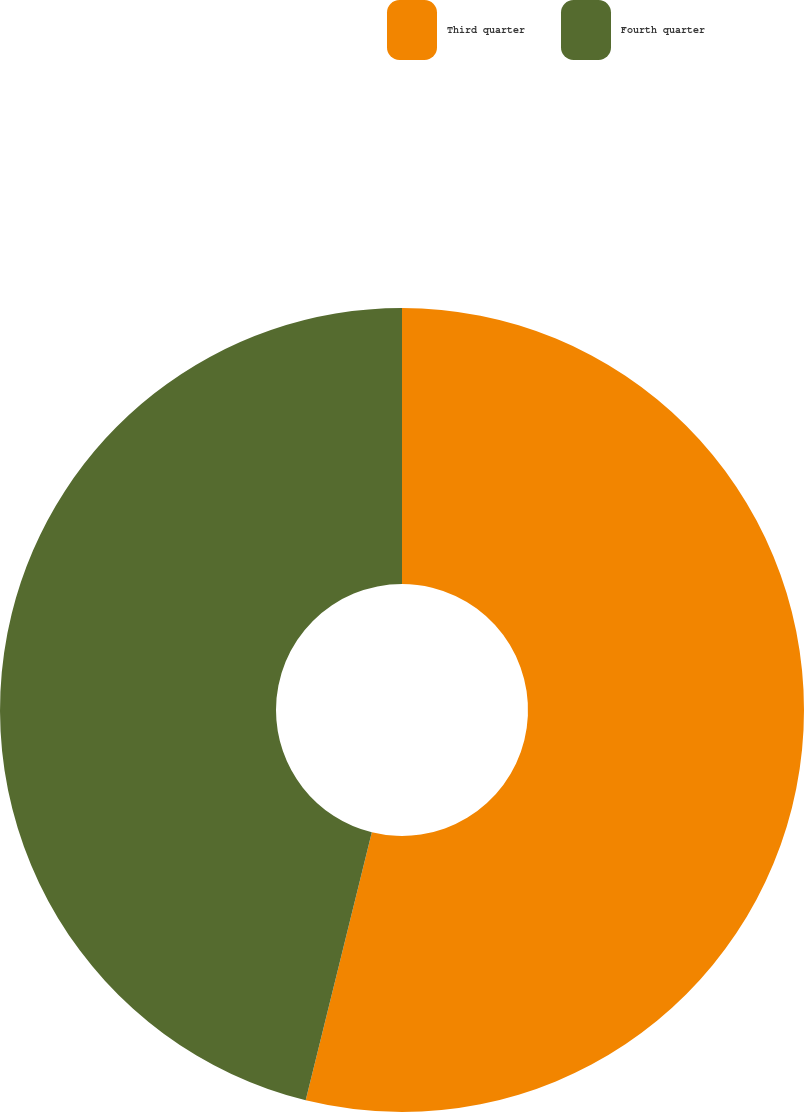Convert chart to OTSL. <chart><loc_0><loc_0><loc_500><loc_500><pie_chart><fcel>Third quarter<fcel>Fourth quarter<nl><fcel>53.85%<fcel>46.15%<nl></chart> 